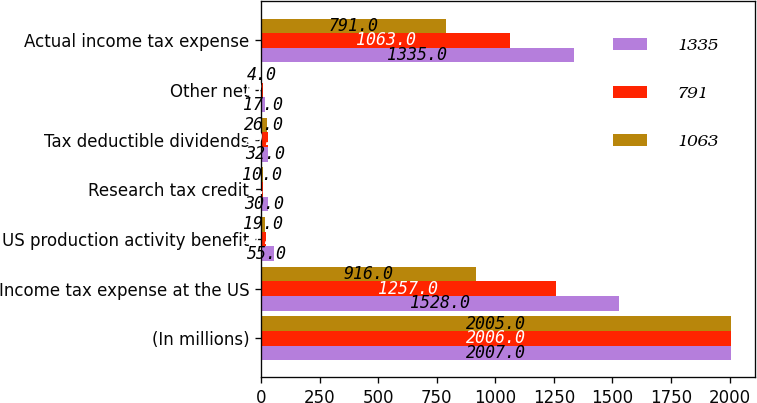Convert chart to OTSL. <chart><loc_0><loc_0><loc_500><loc_500><stacked_bar_chart><ecel><fcel>(In millions)<fcel>Income tax expense at the US<fcel>US production activity benefit<fcel>Research tax credit<fcel>Tax deductible dividends<fcel>Other net<fcel>Actual income tax expense<nl><fcel>1335<fcel>2007<fcel>1528<fcel>55<fcel>30<fcel>32<fcel>17<fcel>1335<nl><fcel>791<fcel>2006<fcel>1257<fcel>21<fcel>9<fcel>29<fcel>10<fcel>1063<nl><fcel>1063<fcel>2005<fcel>916<fcel>19<fcel>10<fcel>26<fcel>4<fcel>791<nl></chart> 